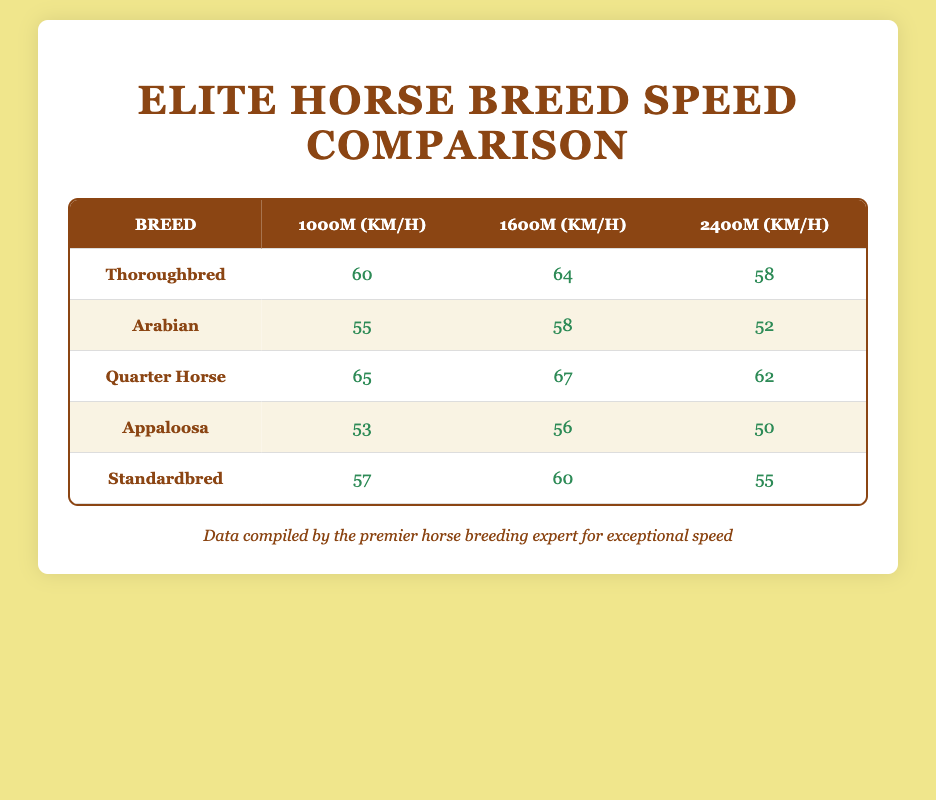What is the average speed of the Quarter Horse over 1600m? The speed for the Quarter Horse over 1600m is listed as 67 km/h in the table. Therefore, the average speed is simply that listed value: 67.
Answer: 67 km/h Which breed has the lowest average speed over 2400m? In the table, the Appaloosa has an average speed of 50 km/h over 2400m, which is lower than the other breeds listed.
Answer: Appaloosa True or False: The Thoroughbred is faster than the Arabian in all distances. The table shows that the Thoroughbred speeds are 60 km/h, 64 km/h, and 58 km/h, while the Arabian speeds are 55 km/h, 58 km/h, and 52 km/h. Since Thoroughbred is faster at each distance, the statement is true.
Answer: True What is the difference in average speed between the Thoroughbred and the Standardbred over 1000m? The average speed of Thoroughbred over 1000m is 60 km/h and that of Standardbred is 57 km/h. We calculate the difference: 60 - 57 = 3.
Answer: 3 km/h Which horse breed has the highest average speed overall across all distances? To find the overall highest average speed, we take the average of the three speeds for each breed. For Quarter Horse, that is (65 + 67 + 62) / 3 = 64.67 km/h; for Thoroughbred, it's (60 + 64 + 58) / 3 = 60.67 km/h; for Arabian (55 + 58 + 52) / 3 = 55 km/h; for Appaloosa (53 + 56 + 50) / 3 = 53 km/h; and for Standardbred (57 + 60 + 55) / 3 = 57.33 km/h. The Quarter Horse has the highest average speed.
Answer: Quarter Horse What is the average speed of the Thoroughbred and Arabian combined over 1600m? The average speed for Thoroughbred over 1600m is 64 km/h and for Arabian it is 58 km/h. The combined average is calculated as (64 + 58) / 2 = 61 km/h.
Answer: 61 km/h 